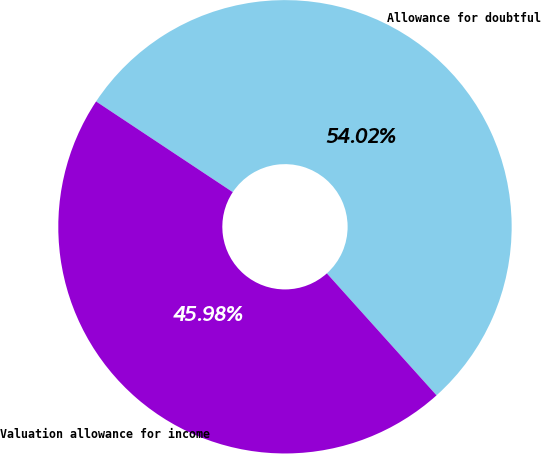Convert chart. <chart><loc_0><loc_0><loc_500><loc_500><pie_chart><fcel>Allowance for doubtful<fcel>Valuation allowance for income<nl><fcel>54.02%<fcel>45.98%<nl></chart> 